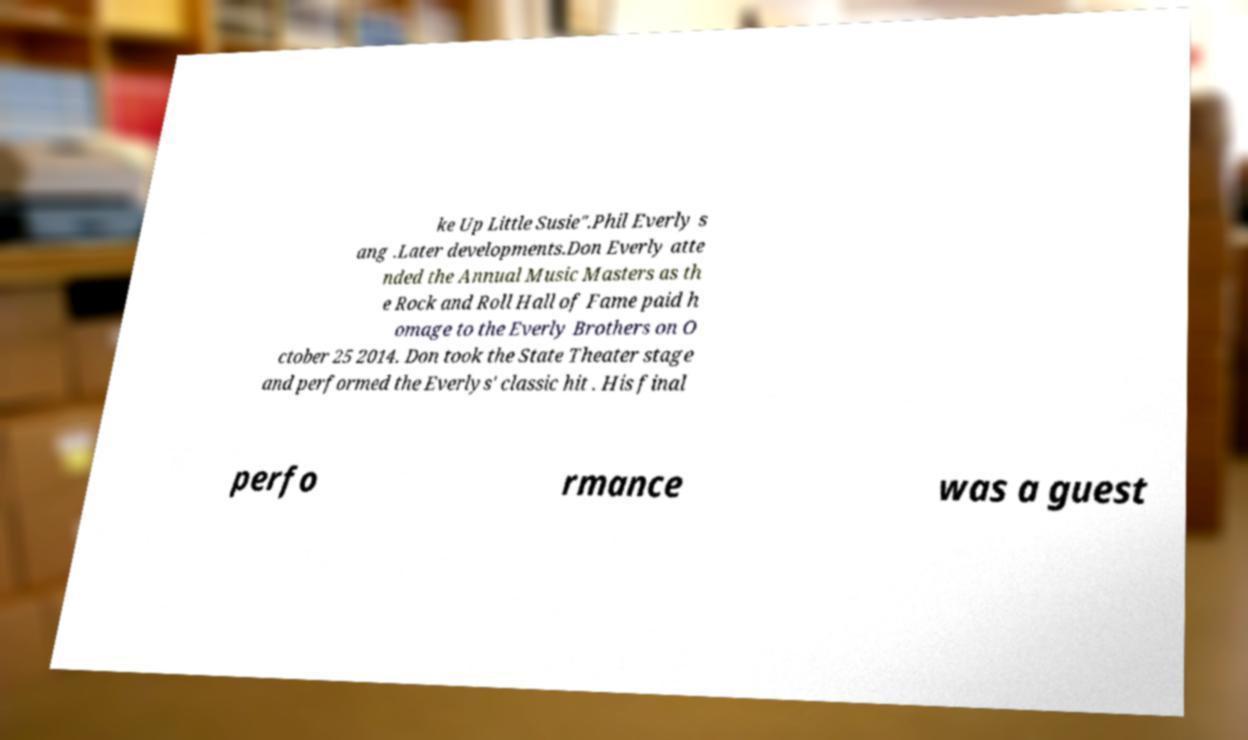Can you read and provide the text displayed in the image?This photo seems to have some interesting text. Can you extract and type it out for me? ke Up Little Susie".Phil Everly s ang .Later developments.Don Everly atte nded the Annual Music Masters as th e Rock and Roll Hall of Fame paid h omage to the Everly Brothers on O ctober 25 2014. Don took the State Theater stage and performed the Everlys' classic hit . His final perfo rmance was a guest 